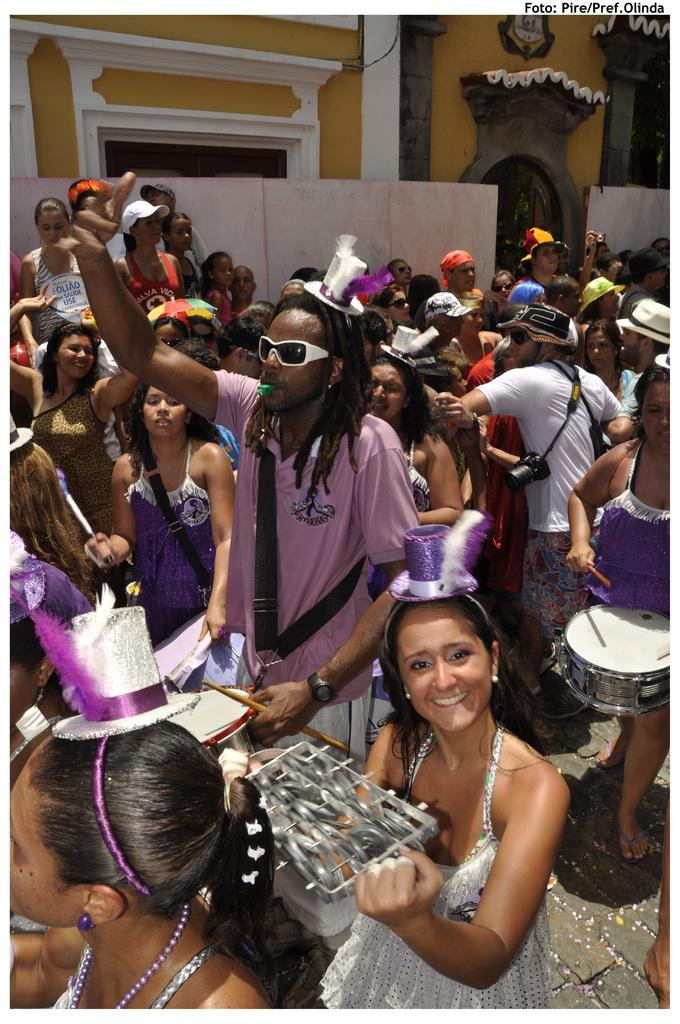How many people are in the image? There are many people in the image. What are some of the people doing in the image? Some of the people are playing musical instruments. What can be seen in the background of the image? There is a building in the background of the image. What is at the bottom of the image? There is a road at the bottom of the image. Where is the desk located in the image? There is no desk present in the image. What is the limit of the people's musical abilities in the image? The image does not provide information about the limits of the people's musical abilities. 